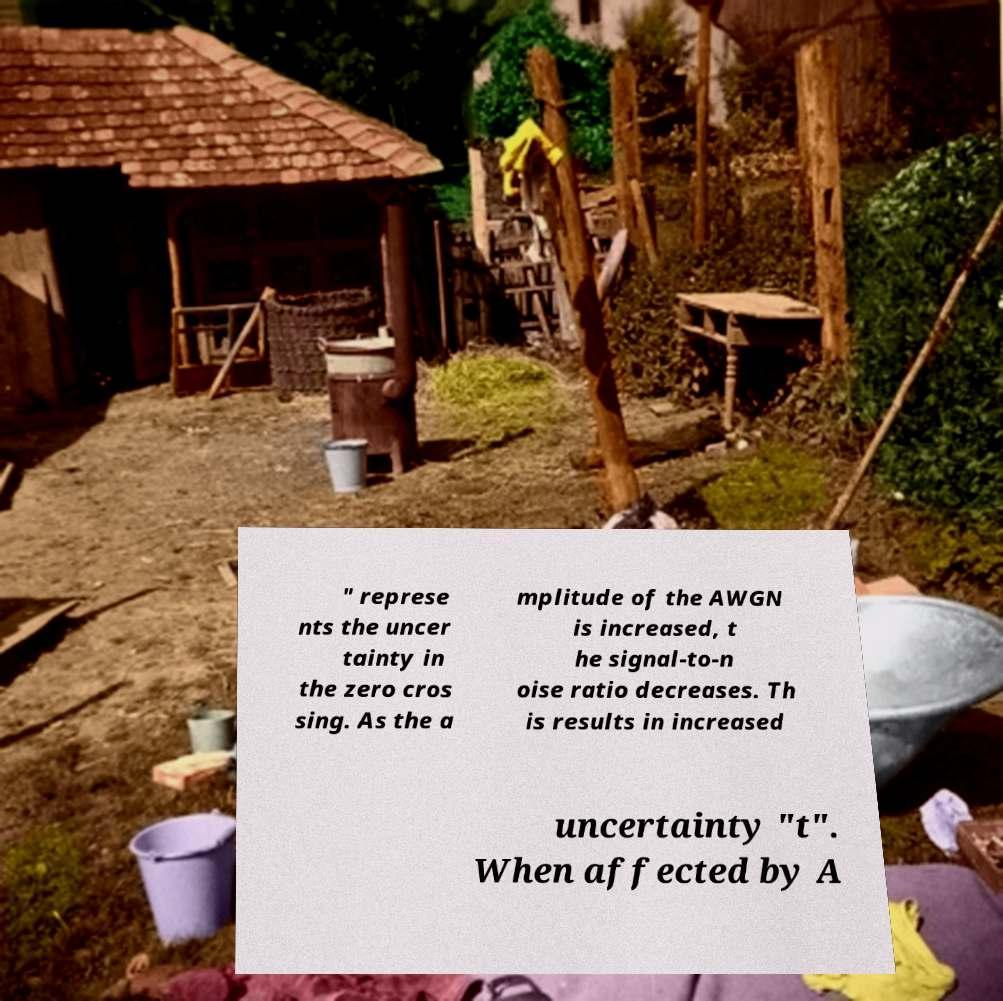Can you accurately transcribe the text from the provided image for me? " represe nts the uncer tainty in the zero cros sing. As the a mplitude of the AWGN is increased, t he signal-to-n oise ratio decreases. Th is results in increased uncertainty "t". When affected by A 